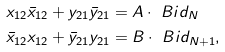Convert formula to latex. <formula><loc_0><loc_0><loc_500><loc_500>& x _ { 1 2 } \bar { x } _ { 1 2 } + y _ { 2 1 } \bar { y } _ { 2 1 } = A \cdot \ B i d _ { N } \\ & \bar { x } _ { 1 2 } x _ { 1 2 } + \bar { y } _ { 2 1 } y _ { 2 1 } = B \cdot \ B i d _ { N + 1 } ,</formula> 